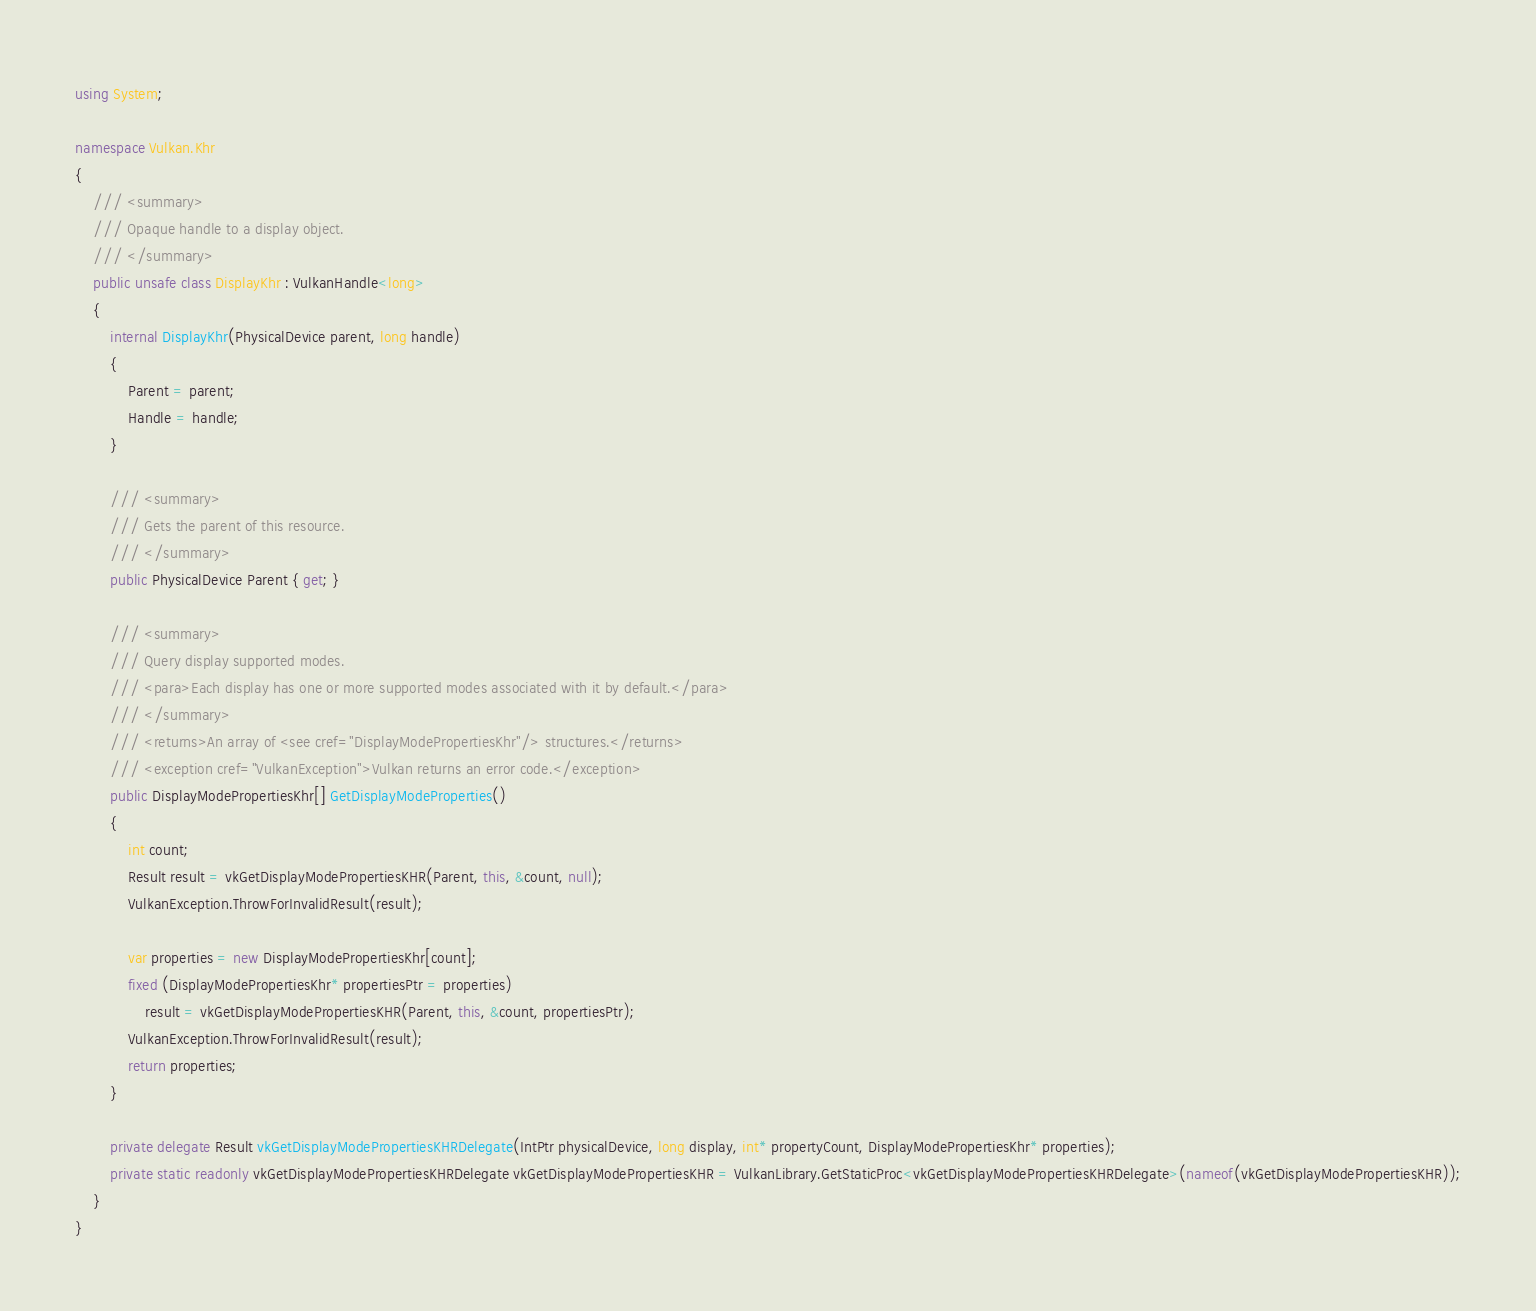Convert code to text. <code><loc_0><loc_0><loc_500><loc_500><_C#_>using System;

namespace Vulkan.Khr
{
    /// <summary>
    /// Opaque handle to a display object.
    /// </summary>
    public unsafe class DisplayKhr : VulkanHandle<long>
    {
        internal DisplayKhr(PhysicalDevice parent, long handle)
        {
            Parent = parent;
            Handle = handle;
        }

        /// <summary>
        /// Gets the parent of this resource.
        /// </summary>
        public PhysicalDevice Parent { get; }

        /// <summary>
        /// Query display supported modes.
        /// <para>Each display has one or more supported modes associated with it by default.</para>
        /// </summary>
        /// <returns>An array of <see cref="DisplayModePropertiesKhr"/> structures.</returns>
        /// <exception cref="VulkanException">Vulkan returns an error code.</exception>
        public DisplayModePropertiesKhr[] GetDisplayModeProperties()
        {
            int count;
            Result result = vkGetDisplayModePropertiesKHR(Parent, this, &count, null);
            VulkanException.ThrowForInvalidResult(result);

            var properties = new DisplayModePropertiesKhr[count];
            fixed (DisplayModePropertiesKhr* propertiesPtr = properties)
                result = vkGetDisplayModePropertiesKHR(Parent, this, &count, propertiesPtr);
            VulkanException.ThrowForInvalidResult(result);
            return properties;
        }

        private delegate Result vkGetDisplayModePropertiesKHRDelegate(IntPtr physicalDevice, long display, int* propertyCount, DisplayModePropertiesKhr* properties);
        private static readonly vkGetDisplayModePropertiesKHRDelegate vkGetDisplayModePropertiesKHR = VulkanLibrary.GetStaticProc<vkGetDisplayModePropertiesKHRDelegate>(nameof(vkGetDisplayModePropertiesKHR));
    }
}
</code> 